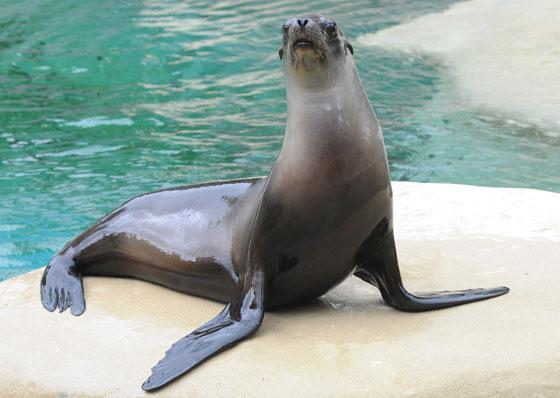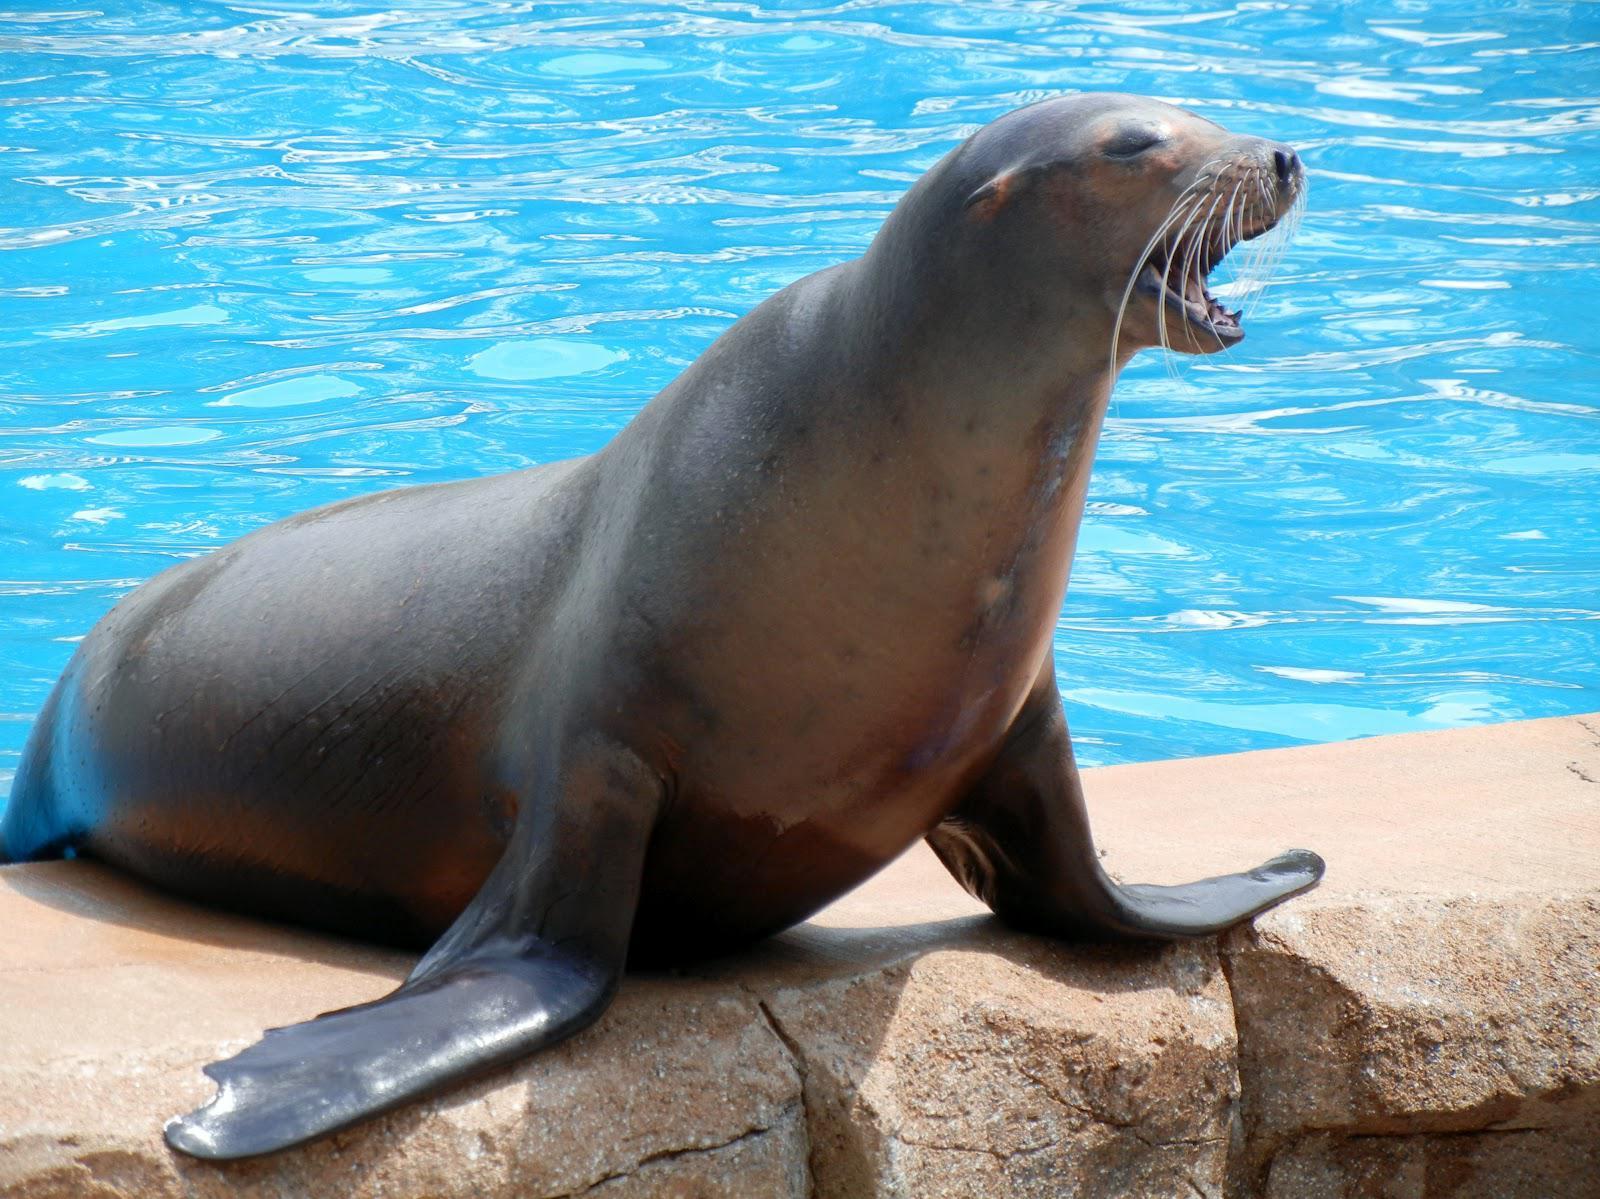The first image is the image on the left, the second image is the image on the right. For the images displayed, is the sentence "Three animals are near the water." factually correct? Answer yes or no. No. The first image is the image on the left, the second image is the image on the right. Examine the images to the left and right. Is the description "At least one image shows a seal on the edge of a man-made pool." accurate? Answer yes or no. Yes. 